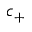Convert formula to latex. <formula><loc_0><loc_0><loc_500><loc_500>c _ { + }</formula> 